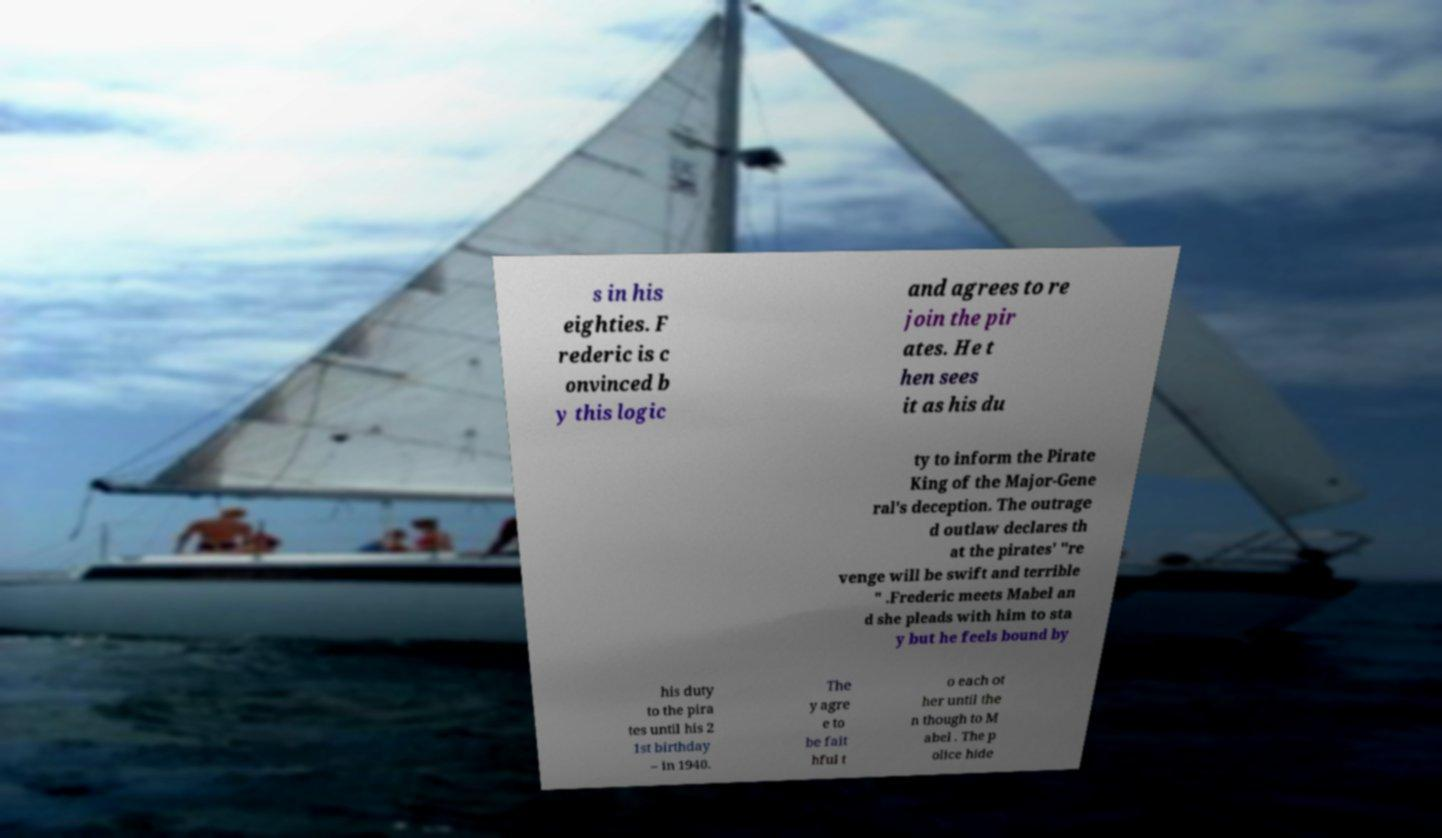For documentation purposes, I need the text within this image transcribed. Could you provide that? s in his eighties. F rederic is c onvinced b y this logic and agrees to re join the pir ates. He t hen sees it as his du ty to inform the Pirate King of the Major-Gene ral's deception. The outrage d outlaw declares th at the pirates' "re venge will be swift and terrible " .Frederic meets Mabel an d she pleads with him to sta y but he feels bound by his duty to the pira tes until his 2 1st birthday – in 1940. The y agre e to be fait hful t o each ot her until the n though to M abel . The p olice hide 